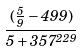<formula> <loc_0><loc_0><loc_500><loc_500>\frac { ( \frac { 5 } { 9 } - 4 9 9 ) } { 5 + 3 5 7 ^ { 2 2 9 } }</formula> 